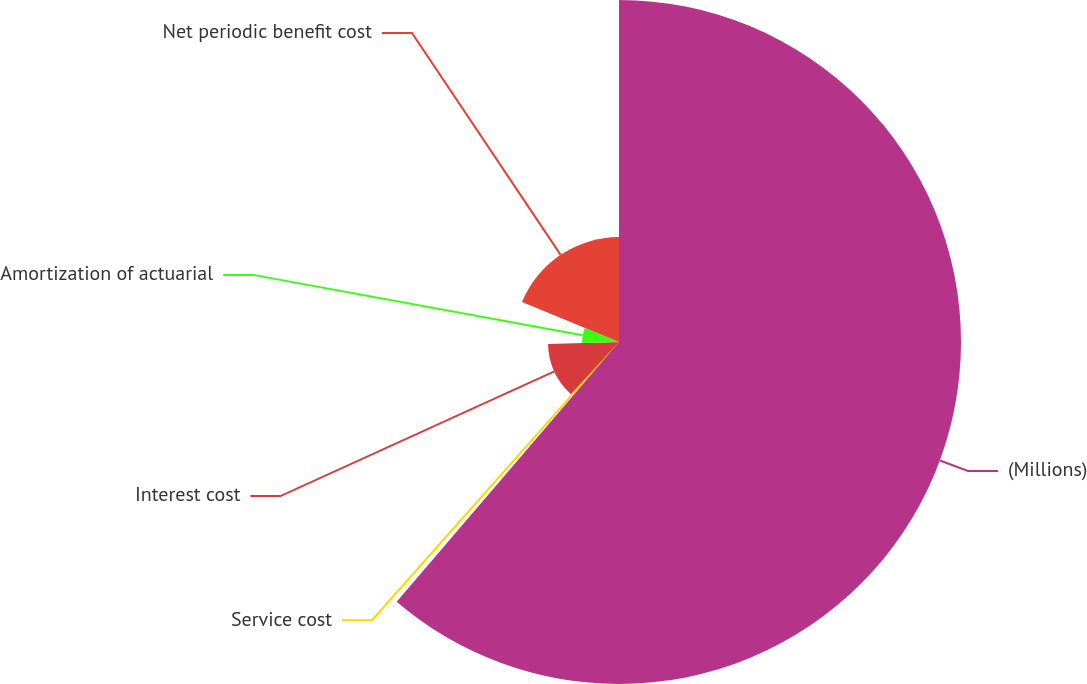<chart> <loc_0><loc_0><loc_500><loc_500><pie_chart><fcel>(Millions)<fcel>Service cost<fcel>Interest cost<fcel>Amortization of actuarial<fcel>Net periodic benefit cost<nl><fcel>61.27%<fcel>0.58%<fcel>12.72%<fcel>6.65%<fcel>18.79%<nl></chart> 